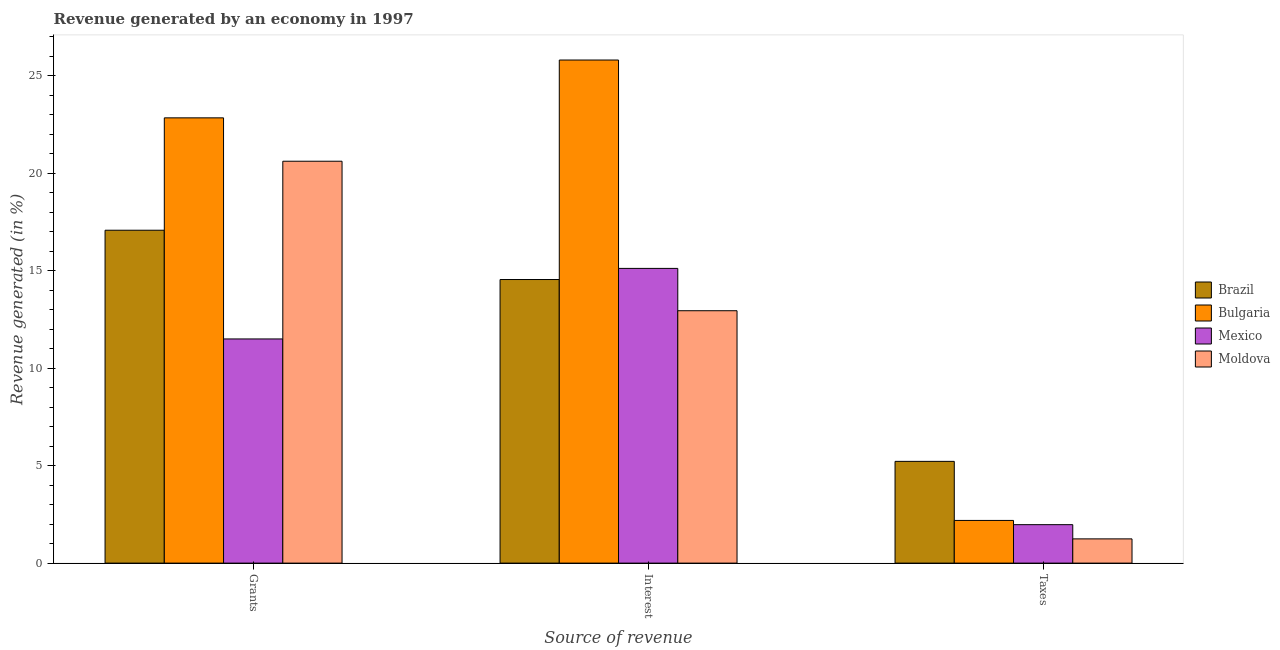Are the number of bars on each tick of the X-axis equal?
Provide a short and direct response. Yes. How many bars are there on the 3rd tick from the left?
Keep it short and to the point. 4. How many bars are there on the 1st tick from the right?
Ensure brevity in your answer.  4. What is the label of the 3rd group of bars from the left?
Your response must be concise. Taxes. What is the percentage of revenue generated by taxes in Bulgaria?
Ensure brevity in your answer.  2.19. Across all countries, what is the maximum percentage of revenue generated by taxes?
Offer a very short reply. 5.22. Across all countries, what is the minimum percentage of revenue generated by grants?
Your answer should be compact. 11.5. In which country was the percentage of revenue generated by taxes minimum?
Offer a very short reply. Moldova. What is the total percentage of revenue generated by grants in the graph?
Ensure brevity in your answer.  72.03. What is the difference between the percentage of revenue generated by taxes in Moldova and that in Brazil?
Your response must be concise. -3.98. What is the difference between the percentage of revenue generated by grants in Moldova and the percentage of revenue generated by taxes in Mexico?
Offer a very short reply. 18.64. What is the average percentage of revenue generated by taxes per country?
Provide a succinct answer. 2.66. What is the difference between the percentage of revenue generated by grants and percentage of revenue generated by taxes in Brazil?
Your response must be concise. 11.86. What is the ratio of the percentage of revenue generated by grants in Mexico to that in Moldova?
Your response must be concise. 0.56. What is the difference between the highest and the second highest percentage of revenue generated by grants?
Keep it short and to the point. 2.22. What is the difference between the highest and the lowest percentage of revenue generated by grants?
Provide a short and direct response. 11.34. Is the sum of the percentage of revenue generated by grants in Moldova and Bulgaria greater than the maximum percentage of revenue generated by interest across all countries?
Your answer should be very brief. Yes. Is it the case that in every country, the sum of the percentage of revenue generated by grants and percentage of revenue generated by interest is greater than the percentage of revenue generated by taxes?
Your answer should be compact. Yes. Are all the bars in the graph horizontal?
Offer a terse response. No. How many countries are there in the graph?
Offer a terse response. 4. What is the difference between two consecutive major ticks on the Y-axis?
Provide a succinct answer. 5. What is the title of the graph?
Offer a terse response. Revenue generated by an economy in 1997. What is the label or title of the X-axis?
Provide a succinct answer. Source of revenue. What is the label or title of the Y-axis?
Provide a succinct answer. Revenue generated (in %). What is the Revenue generated (in %) of Brazil in Grants?
Your answer should be compact. 17.08. What is the Revenue generated (in %) of Bulgaria in Grants?
Your answer should be compact. 22.84. What is the Revenue generated (in %) in Mexico in Grants?
Your answer should be very brief. 11.5. What is the Revenue generated (in %) in Moldova in Grants?
Provide a short and direct response. 20.62. What is the Revenue generated (in %) of Brazil in Interest?
Give a very brief answer. 14.55. What is the Revenue generated (in %) of Bulgaria in Interest?
Offer a terse response. 25.81. What is the Revenue generated (in %) of Mexico in Interest?
Provide a succinct answer. 15.12. What is the Revenue generated (in %) in Moldova in Interest?
Your response must be concise. 12.95. What is the Revenue generated (in %) in Brazil in Taxes?
Ensure brevity in your answer.  5.22. What is the Revenue generated (in %) in Bulgaria in Taxes?
Offer a very short reply. 2.19. What is the Revenue generated (in %) of Mexico in Taxes?
Ensure brevity in your answer.  1.97. What is the Revenue generated (in %) in Moldova in Taxes?
Ensure brevity in your answer.  1.24. Across all Source of revenue, what is the maximum Revenue generated (in %) in Brazil?
Offer a terse response. 17.08. Across all Source of revenue, what is the maximum Revenue generated (in %) of Bulgaria?
Your answer should be compact. 25.81. Across all Source of revenue, what is the maximum Revenue generated (in %) of Mexico?
Your answer should be compact. 15.12. Across all Source of revenue, what is the maximum Revenue generated (in %) of Moldova?
Keep it short and to the point. 20.62. Across all Source of revenue, what is the minimum Revenue generated (in %) of Brazil?
Offer a very short reply. 5.22. Across all Source of revenue, what is the minimum Revenue generated (in %) in Bulgaria?
Give a very brief answer. 2.19. Across all Source of revenue, what is the minimum Revenue generated (in %) in Mexico?
Ensure brevity in your answer.  1.97. Across all Source of revenue, what is the minimum Revenue generated (in %) of Moldova?
Ensure brevity in your answer.  1.24. What is the total Revenue generated (in %) of Brazil in the graph?
Offer a terse response. 36.84. What is the total Revenue generated (in %) of Bulgaria in the graph?
Make the answer very short. 50.84. What is the total Revenue generated (in %) of Mexico in the graph?
Provide a succinct answer. 28.59. What is the total Revenue generated (in %) of Moldova in the graph?
Ensure brevity in your answer.  34.81. What is the difference between the Revenue generated (in %) of Brazil in Grants and that in Interest?
Make the answer very short. 2.53. What is the difference between the Revenue generated (in %) of Bulgaria in Grants and that in Interest?
Make the answer very short. -2.97. What is the difference between the Revenue generated (in %) in Mexico in Grants and that in Interest?
Provide a short and direct response. -3.62. What is the difference between the Revenue generated (in %) of Moldova in Grants and that in Interest?
Your answer should be very brief. 7.67. What is the difference between the Revenue generated (in %) of Brazil in Grants and that in Taxes?
Give a very brief answer. 11.86. What is the difference between the Revenue generated (in %) in Bulgaria in Grants and that in Taxes?
Give a very brief answer. 20.65. What is the difference between the Revenue generated (in %) in Mexico in Grants and that in Taxes?
Make the answer very short. 9.53. What is the difference between the Revenue generated (in %) of Moldova in Grants and that in Taxes?
Your response must be concise. 19.37. What is the difference between the Revenue generated (in %) of Brazil in Interest and that in Taxes?
Offer a terse response. 9.33. What is the difference between the Revenue generated (in %) of Bulgaria in Interest and that in Taxes?
Give a very brief answer. 23.62. What is the difference between the Revenue generated (in %) of Mexico in Interest and that in Taxes?
Make the answer very short. 13.15. What is the difference between the Revenue generated (in %) of Moldova in Interest and that in Taxes?
Your response must be concise. 11.7. What is the difference between the Revenue generated (in %) in Brazil in Grants and the Revenue generated (in %) in Bulgaria in Interest?
Offer a terse response. -8.73. What is the difference between the Revenue generated (in %) in Brazil in Grants and the Revenue generated (in %) in Mexico in Interest?
Provide a short and direct response. 1.96. What is the difference between the Revenue generated (in %) in Brazil in Grants and the Revenue generated (in %) in Moldova in Interest?
Make the answer very short. 4.13. What is the difference between the Revenue generated (in %) of Bulgaria in Grants and the Revenue generated (in %) of Mexico in Interest?
Give a very brief answer. 7.72. What is the difference between the Revenue generated (in %) in Bulgaria in Grants and the Revenue generated (in %) in Moldova in Interest?
Your answer should be very brief. 9.89. What is the difference between the Revenue generated (in %) in Mexico in Grants and the Revenue generated (in %) in Moldova in Interest?
Your answer should be compact. -1.45. What is the difference between the Revenue generated (in %) in Brazil in Grants and the Revenue generated (in %) in Bulgaria in Taxes?
Ensure brevity in your answer.  14.89. What is the difference between the Revenue generated (in %) in Brazil in Grants and the Revenue generated (in %) in Mexico in Taxes?
Your answer should be very brief. 15.1. What is the difference between the Revenue generated (in %) in Brazil in Grants and the Revenue generated (in %) in Moldova in Taxes?
Ensure brevity in your answer.  15.83. What is the difference between the Revenue generated (in %) of Bulgaria in Grants and the Revenue generated (in %) of Mexico in Taxes?
Your answer should be compact. 20.87. What is the difference between the Revenue generated (in %) in Bulgaria in Grants and the Revenue generated (in %) in Moldova in Taxes?
Your response must be concise. 21.6. What is the difference between the Revenue generated (in %) in Mexico in Grants and the Revenue generated (in %) in Moldova in Taxes?
Give a very brief answer. 10.26. What is the difference between the Revenue generated (in %) of Brazil in Interest and the Revenue generated (in %) of Bulgaria in Taxes?
Your answer should be very brief. 12.36. What is the difference between the Revenue generated (in %) in Brazil in Interest and the Revenue generated (in %) in Mexico in Taxes?
Keep it short and to the point. 12.57. What is the difference between the Revenue generated (in %) of Brazil in Interest and the Revenue generated (in %) of Moldova in Taxes?
Keep it short and to the point. 13.3. What is the difference between the Revenue generated (in %) of Bulgaria in Interest and the Revenue generated (in %) of Mexico in Taxes?
Offer a very short reply. 23.83. What is the difference between the Revenue generated (in %) of Bulgaria in Interest and the Revenue generated (in %) of Moldova in Taxes?
Your answer should be compact. 24.56. What is the difference between the Revenue generated (in %) of Mexico in Interest and the Revenue generated (in %) of Moldova in Taxes?
Your answer should be very brief. 13.87. What is the average Revenue generated (in %) in Brazil per Source of revenue?
Offer a terse response. 12.28. What is the average Revenue generated (in %) in Bulgaria per Source of revenue?
Offer a terse response. 16.95. What is the average Revenue generated (in %) of Mexico per Source of revenue?
Your answer should be compact. 9.53. What is the average Revenue generated (in %) of Moldova per Source of revenue?
Keep it short and to the point. 11.6. What is the difference between the Revenue generated (in %) of Brazil and Revenue generated (in %) of Bulgaria in Grants?
Your answer should be very brief. -5.76. What is the difference between the Revenue generated (in %) in Brazil and Revenue generated (in %) in Mexico in Grants?
Offer a terse response. 5.58. What is the difference between the Revenue generated (in %) in Brazil and Revenue generated (in %) in Moldova in Grants?
Keep it short and to the point. -3.54. What is the difference between the Revenue generated (in %) of Bulgaria and Revenue generated (in %) of Mexico in Grants?
Your answer should be compact. 11.34. What is the difference between the Revenue generated (in %) of Bulgaria and Revenue generated (in %) of Moldova in Grants?
Give a very brief answer. 2.22. What is the difference between the Revenue generated (in %) in Mexico and Revenue generated (in %) in Moldova in Grants?
Make the answer very short. -9.12. What is the difference between the Revenue generated (in %) in Brazil and Revenue generated (in %) in Bulgaria in Interest?
Your answer should be compact. -11.26. What is the difference between the Revenue generated (in %) in Brazil and Revenue generated (in %) in Mexico in Interest?
Ensure brevity in your answer.  -0.57. What is the difference between the Revenue generated (in %) in Brazil and Revenue generated (in %) in Moldova in Interest?
Offer a very short reply. 1.6. What is the difference between the Revenue generated (in %) in Bulgaria and Revenue generated (in %) in Mexico in Interest?
Offer a very short reply. 10.69. What is the difference between the Revenue generated (in %) in Bulgaria and Revenue generated (in %) in Moldova in Interest?
Your response must be concise. 12.86. What is the difference between the Revenue generated (in %) in Mexico and Revenue generated (in %) in Moldova in Interest?
Make the answer very short. 2.17. What is the difference between the Revenue generated (in %) of Brazil and Revenue generated (in %) of Bulgaria in Taxes?
Provide a succinct answer. 3.03. What is the difference between the Revenue generated (in %) in Brazil and Revenue generated (in %) in Mexico in Taxes?
Ensure brevity in your answer.  3.25. What is the difference between the Revenue generated (in %) in Brazil and Revenue generated (in %) in Moldova in Taxes?
Provide a short and direct response. 3.98. What is the difference between the Revenue generated (in %) in Bulgaria and Revenue generated (in %) in Mexico in Taxes?
Your answer should be compact. 0.22. What is the difference between the Revenue generated (in %) of Bulgaria and Revenue generated (in %) of Moldova in Taxes?
Provide a short and direct response. 0.95. What is the difference between the Revenue generated (in %) of Mexico and Revenue generated (in %) of Moldova in Taxes?
Make the answer very short. 0.73. What is the ratio of the Revenue generated (in %) in Brazil in Grants to that in Interest?
Keep it short and to the point. 1.17. What is the ratio of the Revenue generated (in %) of Bulgaria in Grants to that in Interest?
Give a very brief answer. 0.89. What is the ratio of the Revenue generated (in %) of Mexico in Grants to that in Interest?
Your answer should be very brief. 0.76. What is the ratio of the Revenue generated (in %) in Moldova in Grants to that in Interest?
Your response must be concise. 1.59. What is the ratio of the Revenue generated (in %) in Brazil in Grants to that in Taxes?
Provide a succinct answer. 3.27. What is the ratio of the Revenue generated (in %) in Bulgaria in Grants to that in Taxes?
Offer a terse response. 10.43. What is the ratio of the Revenue generated (in %) of Mexico in Grants to that in Taxes?
Make the answer very short. 5.83. What is the ratio of the Revenue generated (in %) in Moldova in Grants to that in Taxes?
Ensure brevity in your answer.  16.58. What is the ratio of the Revenue generated (in %) in Brazil in Interest to that in Taxes?
Provide a succinct answer. 2.79. What is the ratio of the Revenue generated (in %) of Bulgaria in Interest to that in Taxes?
Your response must be concise. 11.78. What is the ratio of the Revenue generated (in %) of Mexico in Interest to that in Taxes?
Keep it short and to the point. 7.66. What is the ratio of the Revenue generated (in %) in Moldova in Interest to that in Taxes?
Offer a very short reply. 10.41. What is the difference between the highest and the second highest Revenue generated (in %) of Brazil?
Keep it short and to the point. 2.53. What is the difference between the highest and the second highest Revenue generated (in %) in Bulgaria?
Give a very brief answer. 2.97. What is the difference between the highest and the second highest Revenue generated (in %) of Mexico?
Ensure brevity in your answer.  3.62. What is the difference between the highest and the second highest Revenue generated (in %) of Moldova?
Give a very brief answer. 7.67. What is the difference between the highest and the lowest Revenue generated (in %) of Brazil?
Provide a succinct answer. 11.86. What is the difference between the highest and the lowest Revenue generated (in %) in Bulgaria?
Ensure brevity in your answer.  23.62. What is the difference between the highest and the lowest Revenue generated (in %) of Mexico?
Give a very brief answer. 13.15. What is the difference between the highest and the lowest Revenue generated (in %) of Moldova?
Provide a short and direct response. 19.37. 